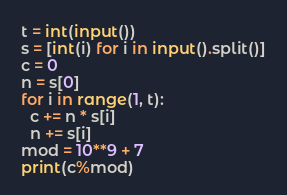Convert code to text. <code><loc_0><loc_0><loc_500><loc_500><_Python_>t = int(input())
s = [int(i) for i in input().split()]
c = 0
n = s[0]
for i in range(1, t):
  c += n * s[i]
  n += s[i]
mod = 10**9 + 7
print(c%mod)</code> 